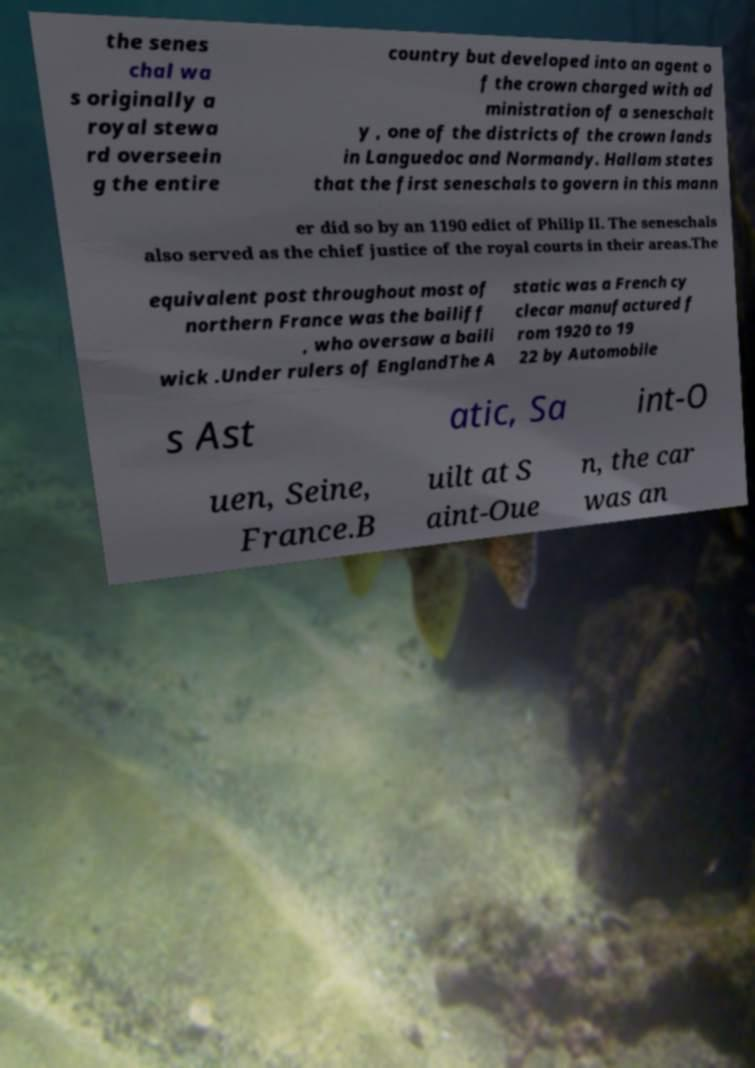What messages or text are displayed in this image? I need them in a readable, typed format. the senes chal wa s originally a royal stewa rd overseein g the entire country but developed into an agent o f the crown charged with ad ministration of a seneschalt y , one of the districts of the crown lands in Languedoc and Normandy. Hallam states that the first seneschals to govern in this mann er did so by an 1190 edict of Philip II. The seneschals also served as the chief justice of the royal courts in their areas.The equivalent post throughout most of northern France was the bailiff , who oversaw a baili wick .Under rulers of EnglandThe A static was a French cy clecar manufactured f rom 1920 to 19 22 by Automobile s Ast atic, Sa int-O uen, Seine, France.B uilt at S aint-Oue n, the car was an 